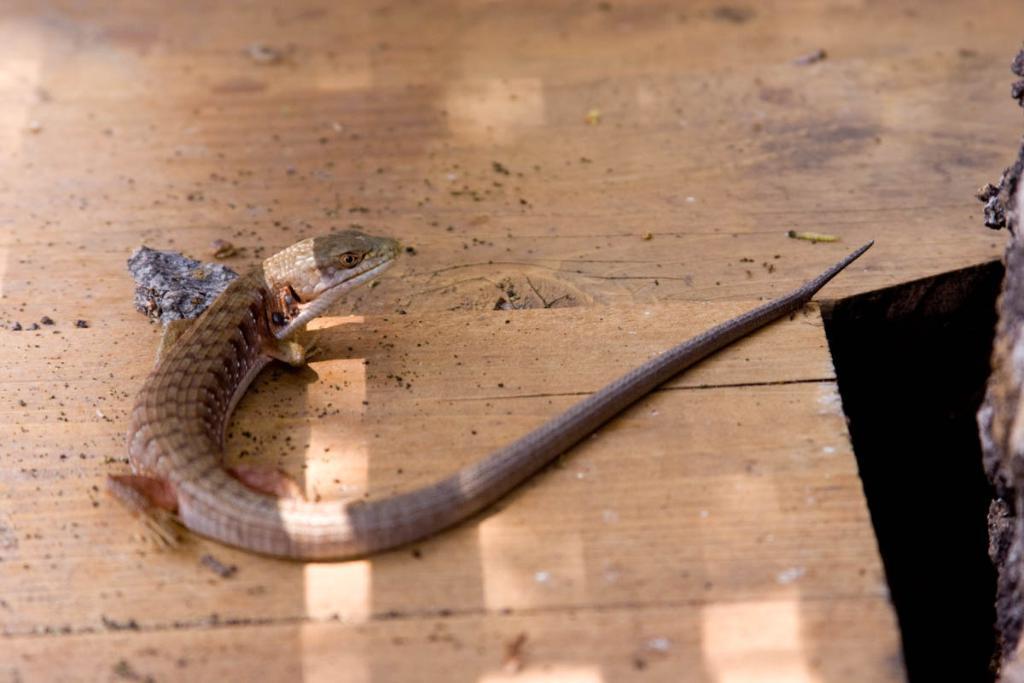Can you describe this image briefly? In the center of the image we can see one snake on the wooden floor and a few other objects. On the right side of the image, we can see one black color object and one more object. 